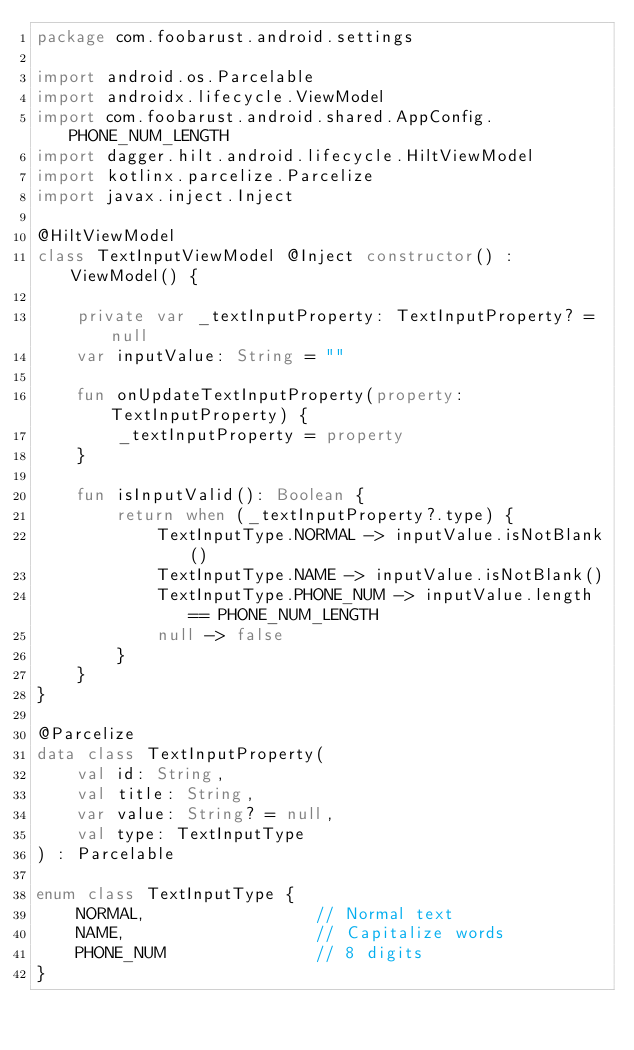Convert code to text. <code><loc_0><loc_0><loc_500><loc_500><_Kotlin_>package com.foobarust.android.settings

import android.os.Parcelable
import androidx.lifecycle.ViewModel
import com.foobarust.android.shared.AppConfig.PHONE_NUM_LENGTH
import dagger.hilt.android.lifecycle.HiltViewModel
import kotlinx.parcelize.Parcelize
import javax.inject.Inject

@HiltViewModel
class TextInputViewModel @Inject constructor() : ViewModel() {

    private var _textInputProperty: TextInputProperty? = null
    var inputValue: String = ""

    fun onUpdateTextInputProperty(property: TextInputProperty) {
        _textInputProperty = property
    }

    fun isInputValid(): Boolean {
        return when (_textInputProperty?.type) {
            TextInputType.NORMAL -> inputValue.isNotBlank()
            TextInputType.NAME -> inputValue.isNotBlank()
            TextInputType.PHONE_NUM -> inputValue.length == PHONE_NUM_LENGTH
            null -> false
        }
    }
}

@Parcelize
data class TextInputProperty(
    val id: String,
    val title: String,
    var value: String? = null,
    val type: TextInputType
) : Parcelable

enum class TextInputType {
    NORMAL,                 // Normal text
    NAME,                   // Capitalize words
    PHONE_NUM               // 8 digits
}</code> 